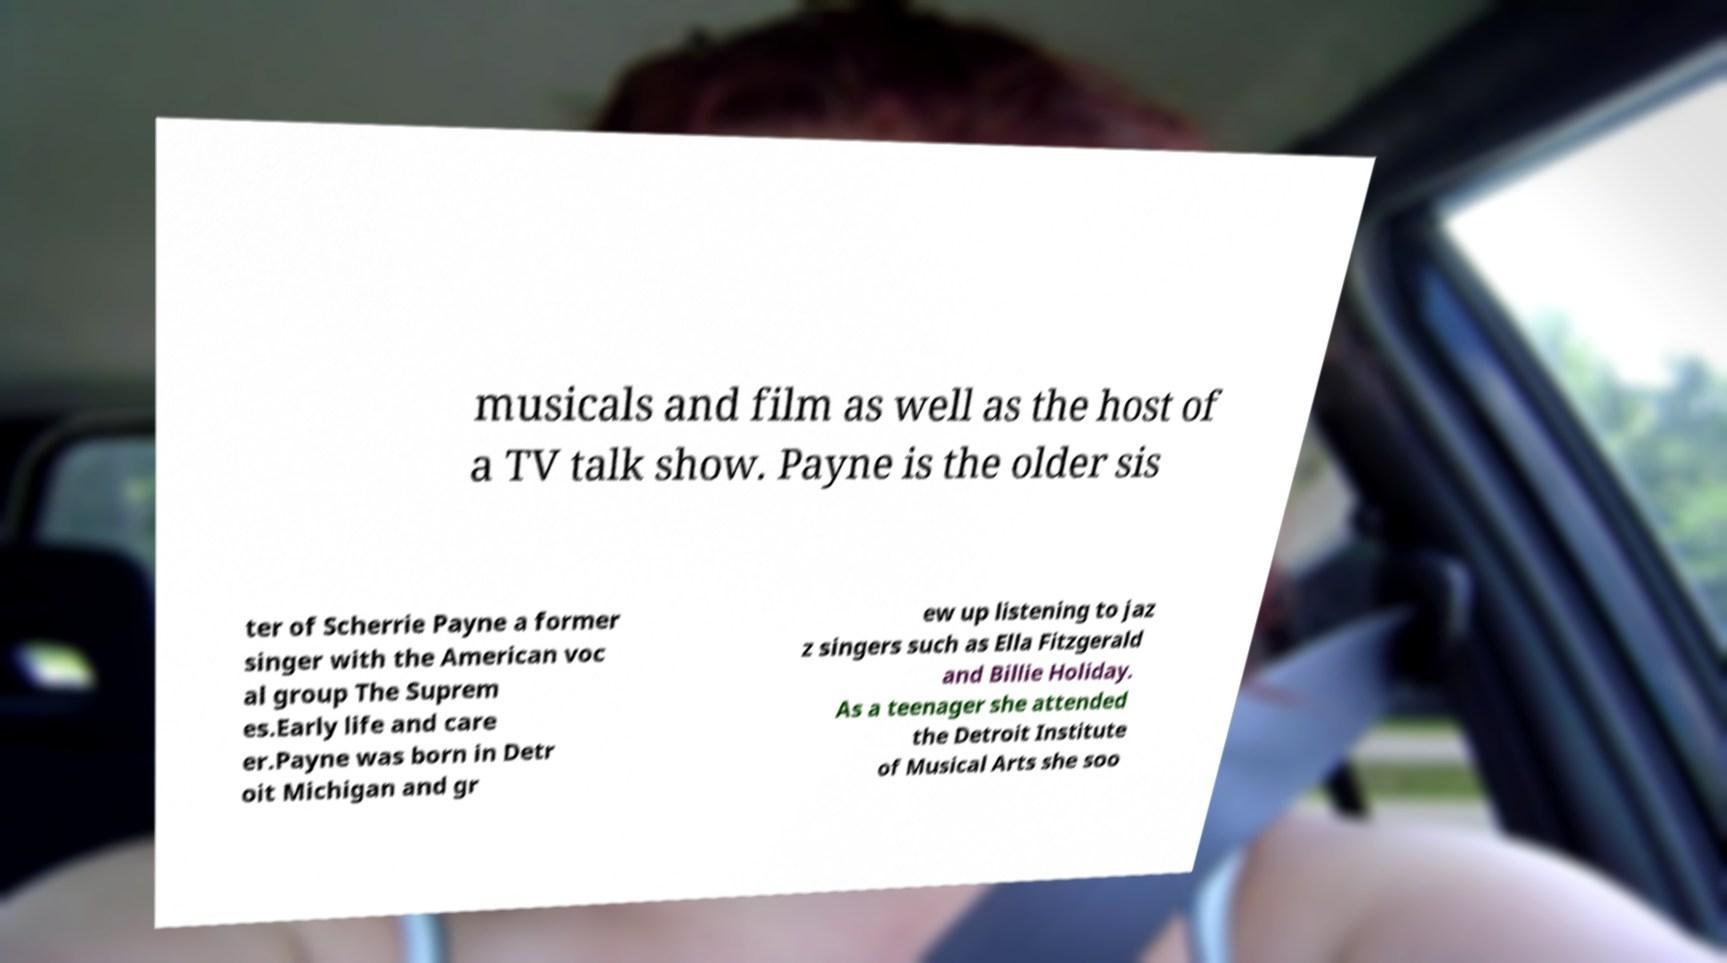Can you read and provide the text displayed in the image?This photo seems to have some interesting text. Can you extract and type it out for me? musicals and film as well as the host of a TV talk show. Payne is the older sis ter of Scherrie Payne a former singer with the American voc al group The Suprem es.Early life and care er.Payne was born in Detr oit Michigan and gr ew up listening to jaz z singers such as Ella Fitzgerald and Billie Holiday. As a teenager she attended the Detroit Institute of Musical Arts she soo 